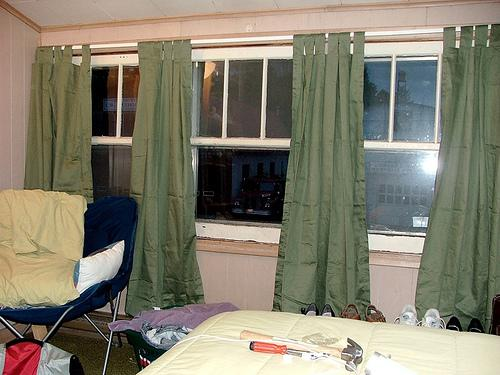What time of day is it likely to be?

Choices:
A) midday
B) evening
C) night
D) morning evening 